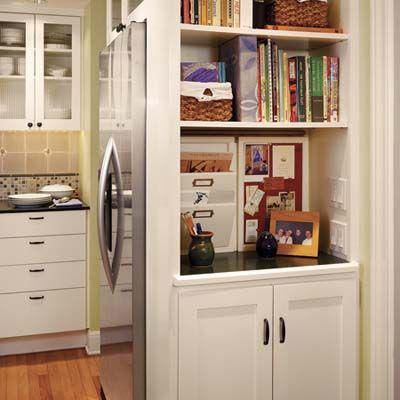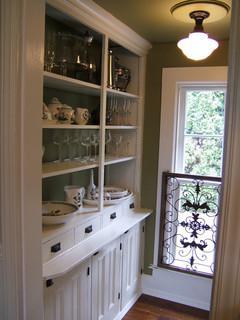The first image is the image on the left, the second image is the image on the right. Examine the images to the left and right. Is the description "In at least one image there is a white bookshelf that is part of a kitchen that include silver appliances." accurate? Answer yes or no. Yes. The first image is the image on the left, the second image is the image on the right. Examine the images to the left and right. Is the description "In one of the images, a doorway with a view into another room is to the right of a tall white bookcase full of books that are mostly arranged vertically." accurate? Answer yes or no. No. 